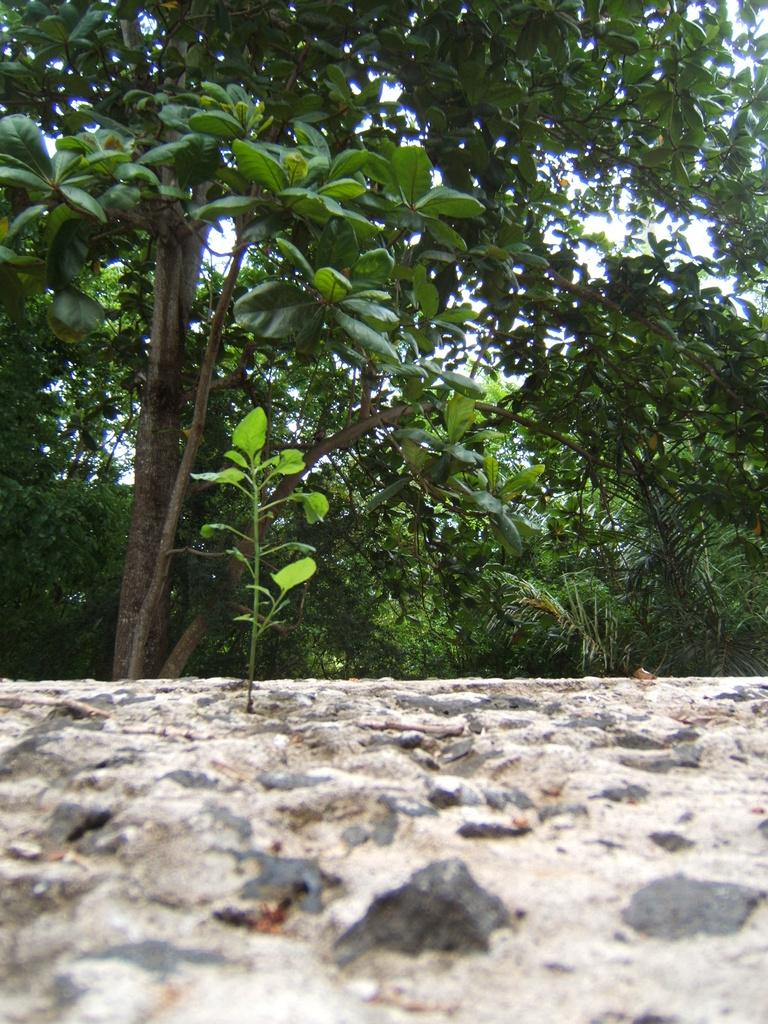What type of living organism can be seen in the image? There is a plant in the image. What type of surface is visible in the image? There is a rock surface in the image. What can be seen in the background of the image? Trees and the sky are visible in the background of the image. What type of bed is visible in the image? There is no bed present in the image. How does the plant attempt to climb the rock surface in the image? The plant does not attempt to climb the rock surface in the image; it is stationary. 